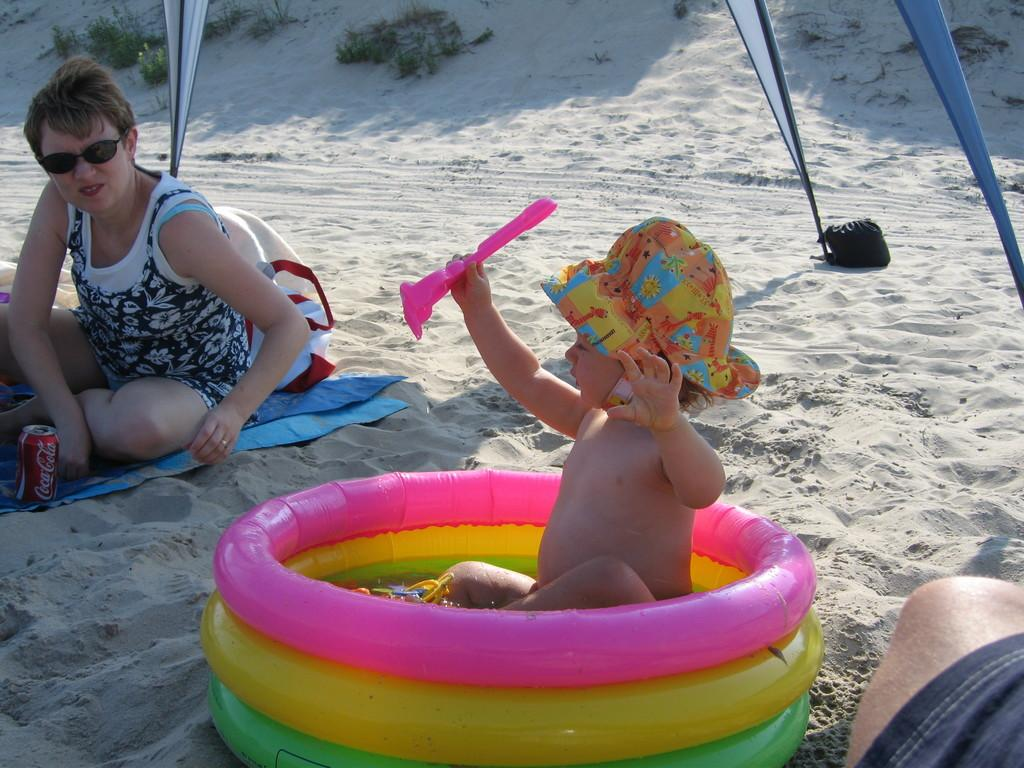Who is present in the image? There is a woman and a child in the image. What is the woman wearing? The woman is wearing shades. What can be seen in the background of the image? There is grass visible in the background of the image. What else is present in the image besides the woman and child? There are tubes of different colors in the image. What type of flag is being waved by the creator in the image? There is no flag or creator present in the image. How many houses can be seen in the image? There are no houses visible in the image. 